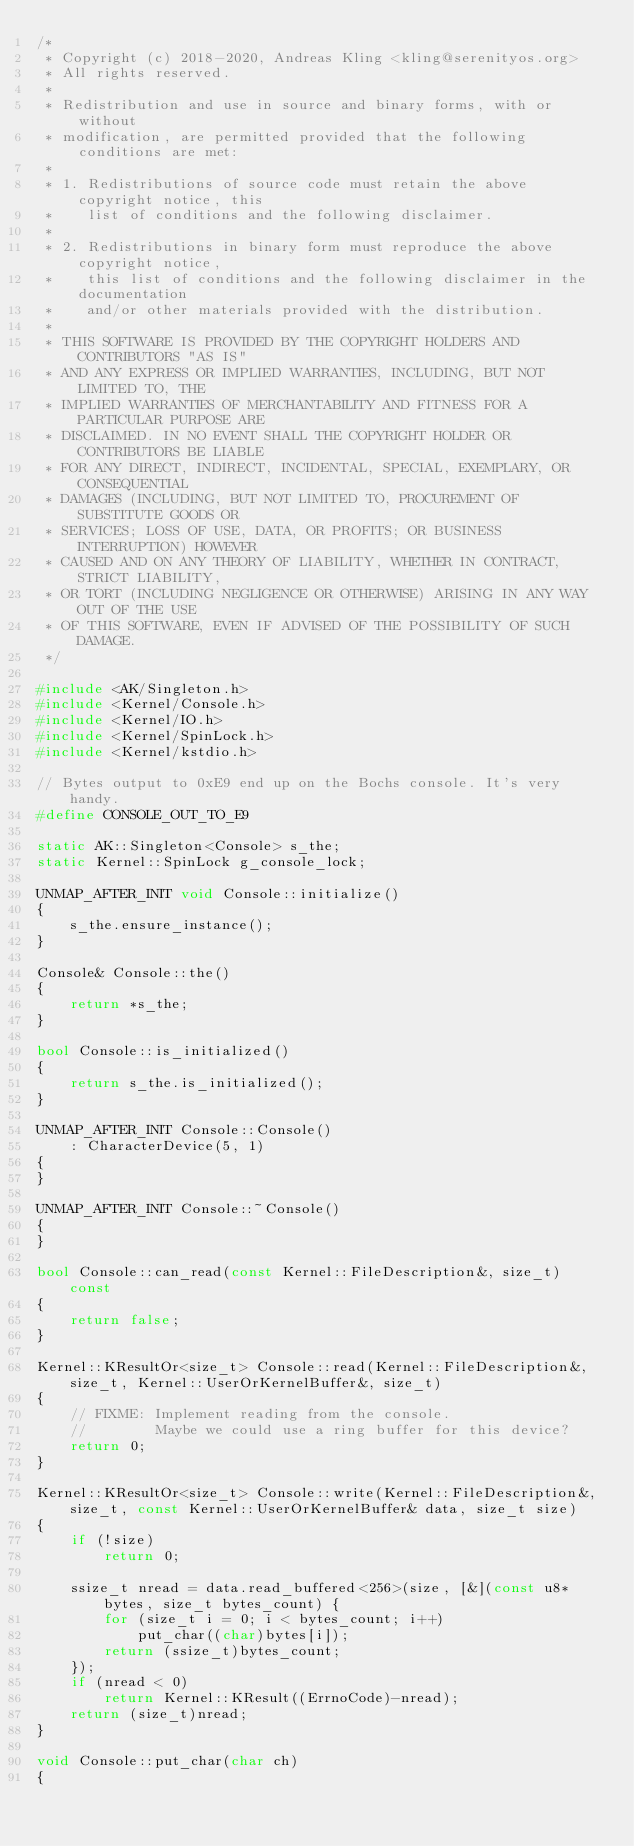<code> <loc_0><loc_0><loc_500><loc_500><_C++_>/*
 * Copyright (c) 2018-2020, Andreas Kling <kling@serenityos.org>
 * All rights reserved.
 *
 * Redistribution and use in source and binary forms, with or without
 * modification, are permitted provided that the following conditions are met:
 *
 * 1. Redistributions of source code must retain the above copyright notice, this
 *    list of conditions and the following disclaimer.
 *
 * 2. Redistributions in binary form must reproduce the above copyright notice,
 *    this list of conditions and the following disclaimer in the documentation
 *    and/or other materials provided with the distribution.
 *
 * THIS SOFTWARE IS PROVIDED BY THE COPYRIGHT HOLDERS AND CONTRIBUTORS "AS IS"
 * AND ANY EXPRESS OR IMPLIED WARRANTIES, INCLUDING, BUT NOT LIMITED TO, THE
 * IMPLIED WARRANTIES OF MERCHANTABILITY AND FITNESS FOR A PARTICULAR PURPOSE ARE
 * DISCLAIMED. IN NO EVENT SHALL THE COPYRIGHT HOLDER OR CONTRIBUTORS BE LIABLE
 * FOR ANY DIRECT, INDIRECT, INCIDENTAL, SPECIAL, EXEMPLARY, OR CONSEQUENTIAL
 * DAMAGES (INCLUDING, BUT NOT LIMITED TO, PROCUREMENT OF SUBSTITUTE GOODS OR
 * SERVICES; LOSS OF USE, DATA, OR PROFITS; OR BUSINESS INTERRUPTION) HOWEVER
 * CAUSED AND ON ANY THEORY OF LIABILITY, WHETHER IN CONTRACT, STRICT LIABILITY,
 * OR TORT (INCLUDING NEGLIGENCE OR OTHERWISE) ARISING IN ANY WAY OUT OF THE USE
 * OF THIS SOFTWARE, EVEN IF ADVISED OF THE POSSIBILITY OF SUCH DAMAGE.
 */

#include <AK/Singleton.h>
#include <Kernel/Console.h>
#include <Kernel/IO.h>
#include <Kernel/SpinLock.h>
#include <Kernel/kstdio.h>

// Bytes output to 0xE9 end up on the Bochs console. It's very handy.
#define CONSOLE_OUT_TO_E9

static AK::Singleton<Console> s_the;
static Kernel::SpinLock g_console_lock;

UNMAP_AFTER_INIT void Console::initialize()
{
    s_the.ensure_instance();
}

Console& Console::the()
{
    return *s_the;
}

bool Console::is_initialized()
{
    return s_the.is_initialized();
}

UNMAP_AFTER_INIT Console::Console()
    : CharacterDevice(5, 1)
{
}

UNMAP_AFTER_INIT Console::~Console()
{
}

bool Console::can_read(const Kernel::FileDescription&, size_t) const
{
    return false;
}

Kernel::KResultOr<size_t> Console::read(Kernel::FileDescription&, size_t, Kernel::UserOrKernelBuffer&, size_t)
{
    // FIXME: Implement reading from the console.
    //        Maybe we could use a ring buffer for this device?
    return 0;
}

Kernel::KResultOr<size_t> Console::write(Kernel::FileDescription&, size_t, const Kernel::UserOrKernelBuffer& data, size_t size)
{
    if (!size)
        return 0;

    ssize_t nread = data.read_buffered<256>(size, [&](const u8* bytes, size_t bytes_count) {
        for (size_t i = 0; i < bytes_count; i++)
            put_char((char)bytes[i]);
        return (ssize_t)bytes_count;
    });
    if (nread < 0)
        return Kernel::KResult((ErrnoCode)-nread);
    return (size_t)nread;
}

void Console::put_char(char ch)
{</code> 